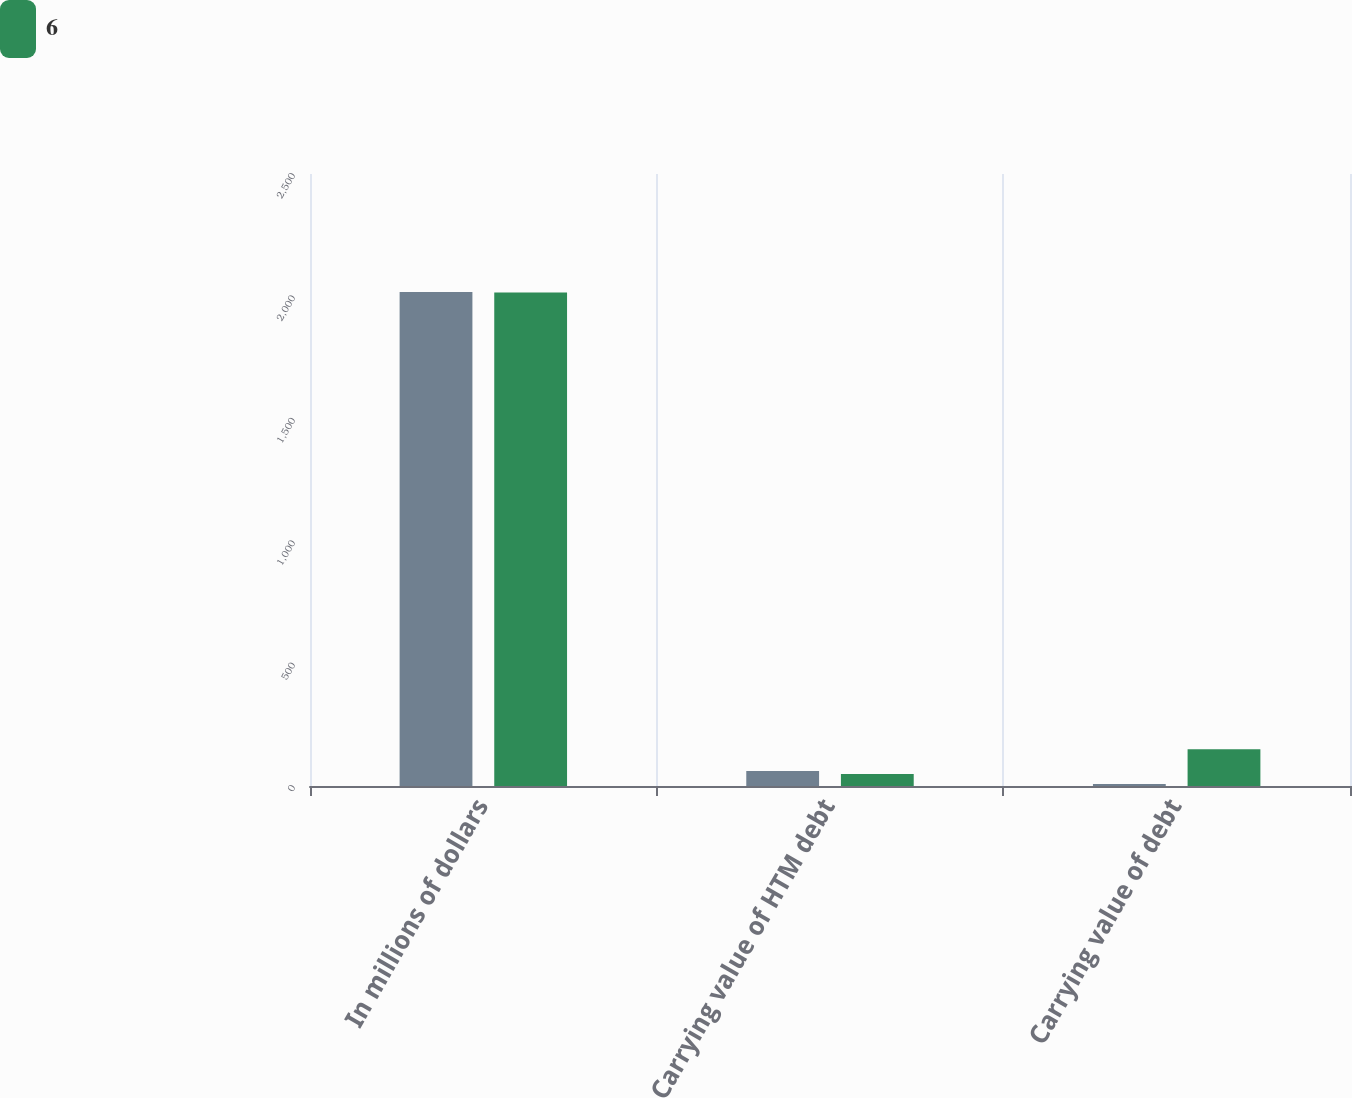<chart> <loc_0><loc_0><loc_500><loc_500><stacked_bar_chart><ecel><fcel>In millions of dollars<fcel>Carrying value of HTM debt<fcel>Carrying value of debt<nl><fcel>nan<fcel>2018<fcel>61<fcel>8<nl><fcel>6<fcel>2016<fcel>49<fcel>150<nl></chart> 